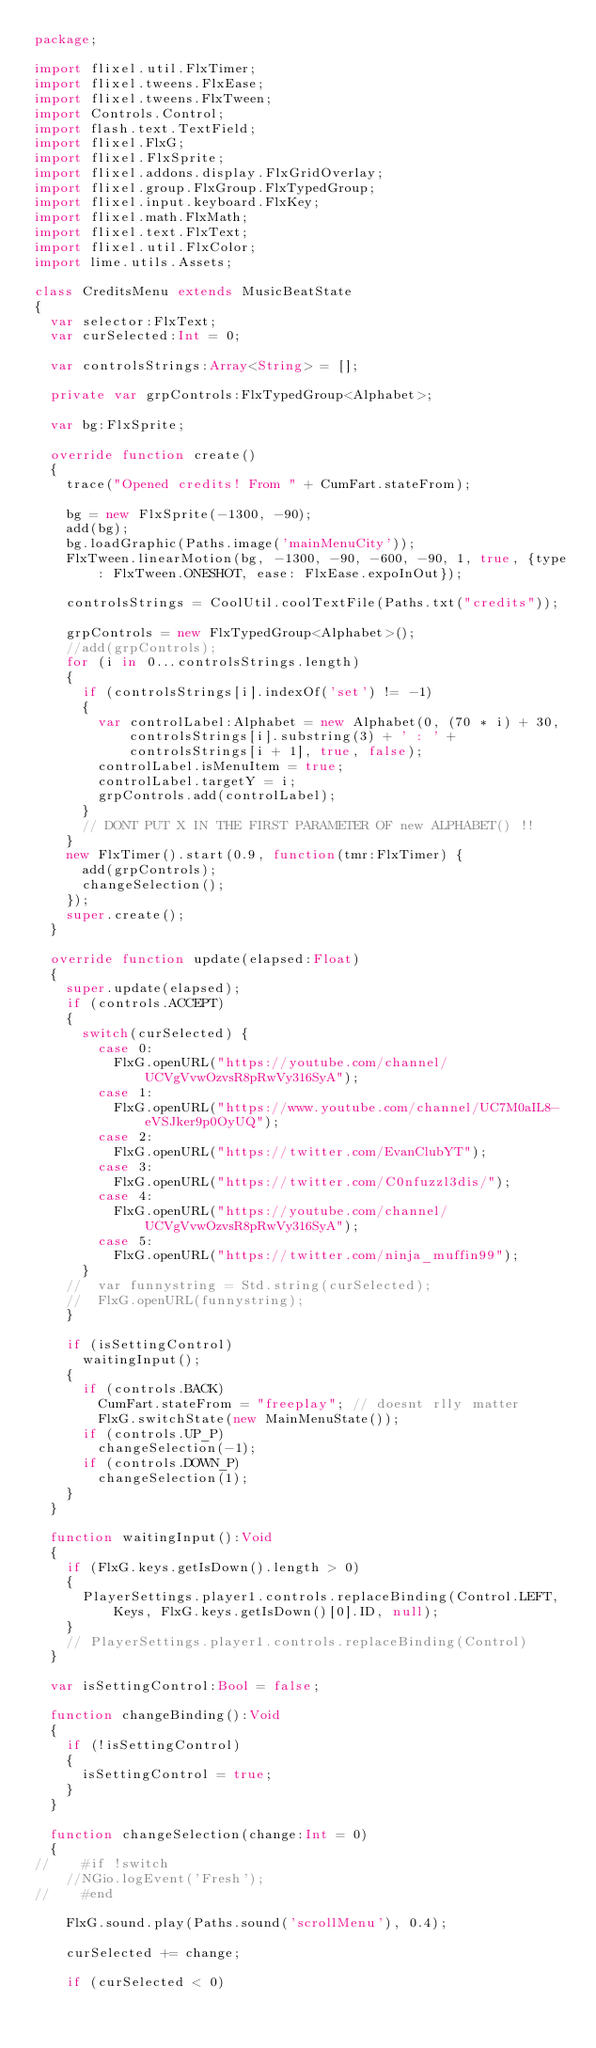Convert code to text. <code><loc_0><loc_0><loc_500><loc_500><_Haxe_>package;

import flixel.util.FlxTimer;
import flixel.tweens.FlxEase;
import flixel.tweens.FlxTween;
import Controls.Control;
import flash.text.TextField;
import flixel.FlxG;
import flixel.FlxSprite;
import flixel.addons.display.FlxGridOverlay;
import flixel.group.FlxGroup.FlxTypedGroup;
import flixel.input.keyboard.FlxKey;
import flixel.math.FlxMath;
import flixel.text.FlxText;
import flixel.util.FlxColor;
import lime.utils.Assets;

class CreditsMenu extends MusicBeatState
{
	var selector:FlxText;
	var curSelected:Int = 0;

	var controlsStrings:Array<String> = [];

	private var grpControls:FlxTypedGroup<Alphabet>;

	var bg:FlxSprite;

	override function create()
	{
		trace("Opened credits! From " + CumFart.stateFrom);

		bg = new FlxSprite(-1300, -90);
		add(bg);
		bg.loadGraphic(Paths.image('mainMenuCity'));
		FlxTween.linearMotion(bg, -1300, -90, -600, -90, 1, true, {type: FlxTween.ONESHOT, ease: FlxEase.expoInOut});

		controlsStrings = CoolUtil.coolTextFile(Paths.txt("credits"));

		grpControls = new FlxTypedGroup<Alphabet>();
		//add(grpControls);
		for (i in 0...controlsStrings.length)
		{
			if (controlsStrings[i].indexOf('set') != -1)
			{
				var controlLabel:Alphabet = new Alphabet(0, (70 * i) + 30, controlsStrings[i].substring(3) + ' : ' + controlsStrings[i + 1], true, false);
				controlLabel.isMenuItem = true;
				controlLabel.targetY = i;
				grpControls.add(controlLabel);
			}
			// DONT PUT X IN THE FIRST PARAMETER OF new ALPHABET() !!
		}
		new FlxTimer().start(0.9, function(tmr:FlxTimer) {
			add(grpControls);
			changeSelection();
		});
		super.create();
	}

	override function update(elapsed:Float)
	{
		super.update(elapsed);
		if (controls.ACCEPT)
		{
			switch(curSelected) {
				case 0:
					FlxG.openURL("https://youtube.com/channel/UCVgVvwOzvsR8pRwVy316SyA");
				case 1:
					FlxG.openURL("https://www.youtube.com/channel/UC7M0aIL8-eVSJker9p0OyUQ");
				case 2:
					FlxG.openURL("https://twitter.com/EvanClubYT");
				case 3:
					FlxG.openURL("https://twitter.com/C0nfuzzl3dis/");
				case 4:
					FlxG.openURL("https://youtube.com/channel/UCVgVvwOzvsR8pRwVy316SyA");
				case 5:
					FlxG.openURL("https://twitter.com/ninja_muffin99");
			}
		//	var funnystring = Std.string(curSelected);
		//	FlxG.openURL(funnystring); 
		}

		if (isSettingControl)
			waitingInput();
		{
			if (controls.BACK)
				CumFart.stateFrom = "freeplay"; // doesnt rlly matter
				FlxG.switchState(new MainMenuState());
			if (controls.UP_P)
				changeSelection(-1);
			if (controls.DOWN_P)
				changeSelection(1);
		}
	}

	function waitingInput():Void
	{
		if (FlxG.keys.getIsDown().length > 0)
		{
			PlayerSettings.player1.controls.replaceBinding(Control.LEFT, Keys, FlxG.keys.getIsDown()[0].ID, null);
		}
		// PlayerSettings.player1.controls.replaceBinding(Control)
	}

	var isSettingControl:Bool = false;

	function changeBinding():Void
	{
		if (!isSettingControl)
		{
			isSettingControl = true;
		}
	}

	function changeSelection(change:Int = 0)
	{
//		#if !switch
		//NGio.logEvent('Fresh');
//		#end

		FlxG.sound.play(Paths.sound('scrollMenu'), 0.4);

		curSelected += change;

		if (curSelected < 0)</code> 